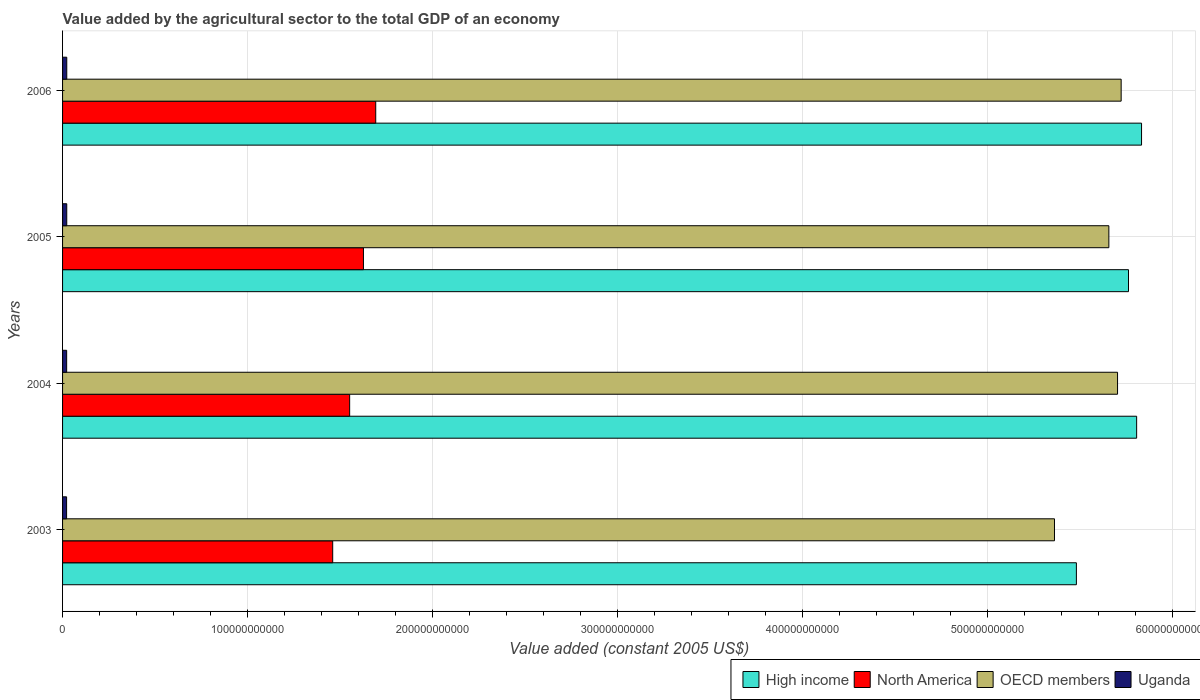In how many cases, is the number of bars for a given year not equal to the number of legend labels?
Your response must be concise. 0. What is the value added by the agricultural sector in OECD members in 2006?
Give a very brief answer. 5.72e+11. Across all years, what is the maximum value added by the agricultural sector in High income?
Your response must be concise. 5.84e+11. Across all years, what is the minimum value added by the agricultural sector in Uganda?
Give a very brief answer. 2.18e+09. In which year was the value added by the agricultural sector in North America maximum?
Offer a very short reply. 2006. What is the total value added by the agricultural sector in High income in the graph?
Provide a succinct answer. 2.29e+12. What is the difference between the value added by the agricultural sector in High income in 2004 and that in 2005?
Your answer should be compact. 4.40e+09. What is the difference between the value added by the agricultural sector in OECD members in 2005 and the value added by the agricultural sector in High income in 2003?
Provide a succinct answer. 1.76e+1. What is the average value added by the agricultural sector in High income per year?
Offer a very short reply. 5.72e+11. In the year 2004, what is the difference between the value added by the agricultural sector in OECD members and value added by the agricultural sector in Uganda?
Offer a terse response. 5.68e+11. What is the ratio of the value added by the agricultural sector in OECD members in 2003 to that in 2006?
Give a very brief answer. 0.94. Is the value added by the agricultural sector in North America in 2003 less than that in 2005?
Offer a terse response. Yes. Is the difference between the value added by the agricultural sector in OECD members in 2003 and 2006 greater than the difference between the value added by the agricultural sector in Uganda in 2003 and 2006?
Provide a succinct answer. No. What is the difference between the highest and the second highest value added by the agricultural sector in High income?
Give a very brief answer. 2.66e+09. What is the difference between the highest and the lowest value added by the agricultural sector in Uganda?
Give a very brief answer. 9.04e+07. Is the sum of the value added by the agricultural sector in Uganda in 2003 and 2006 greater than the maximum value added by the agricultural sector in North America across all years?
Offer a terse response. No. What does the 1st bar from the top in 2004 represents?
Offer a terse response. Uganda. How many bars are there?
Your answer should be compact. 16. Are all the bars in the graph horizontal?
Your answer should be very brief. Yes. How many years are there in the graph?
Ensure brevity in your answer.  4. What is the difference between two consecutive major ticks on the X-axis?
Your response must be concise. 1.00e+11. Are the values on the major ticks of X-axis written in scientific E-notation?
Offer a terse response. No. Does the graph contain any zero values?
Your response must be concise. No. Where does the legend appear in the graph?
Offer a very short reply. Bottom right. What is the title of the graph?
Offer a terse response. Value added by the agricultural sector to the total GDP of an economy. Does "High income: nonOECD" appear as one of the legend labels in the graph?
Provide a short and direct response. No. What is the label or title of the X-axis?
Your answer should be very brief. Value added (constant 2005 US$). What is the Value added (constant 2005 US$) of High income in 2003?
Give a very brief answer. 5.48e+11. What is the Value added (constant 2005 US$) of North America in 2003?
Give a very brief answer. 1.46e+11. What is the Value added (constant 2005 US$) of OECD members in 2003?
Make the answer very short. 5.36e+11. What is the Value added (constant 2005 US$) in Uganda in 2003?
Your answer should be very brief. 2.18e+09. What is the Value added (constant 2005 US$) of High income in 2004?
Provide a succinct answer. 5.81e+11. What is the Value added (constant 2005 US$) of North America in 2004?
Your answer should be very brief. 1.55e+11. What is the Value added (constant 2005 US$) in OECD members in 2004?
Give a very brief answer. 5.71e+11. What is the Value added (constant 2005 US$) of Uganda in 2004?
Make the answer very short. 2.21e+09. What is the Value added (constant 2005 US$) in High income in 2005?
Offer a terse response. 5.76e+11. What is the Value added (constant 2005 US$) of North America in 2005?
Offer a terse response. 1.63e+11. What is the Value added (constant 2005 US$) in OECD members in 2005?
Your response must be concise. 5.66e+11. What is the Value added (constant 2005 US$) of Uganda in 2005?
Ensure brevity in your answer.  2.26e+09. What is the Value added (constant 2005 US$) of High income in 2006?
Your answer should be compact. 5.84e+11. What is the Value added (constant 2005 US$) of North America in 2006?
Give a very brief answer. 1.69e+11. What is the Value added (constant 2005 US$) in OECD members in 2006?
Your response must be concise. 5.72e+11. What is the Value added (constant 2005 US$) in Uganda in 2006?
Make the answer very short. 2.27e+09. Across all years, what is the maximum Value added (constant 2005 US$) of High income?
Your response must be concise. 5.84e+11. Across all years, what is the maximum Value added (constant 2005 US$) of North America?
Your answer should be very brief. 1.69e+11. Across all years, what is the maximum Value added (constant 2005 US$) of OECD members?
Ensure brevity in your answer.  5.72e+11. Across all years, what is the maximum Value added (constant 2005 US$) of Uganda?
Provide a succinct answer. 2.27e+09. Across all years, what is the minimum Value added (constant 2005 US$) in High income?
Your response must be concise. 5.48e+11. Across all years, what is the minimum Value added (constant 2005 US$) in North America?
Keep it short and to the point. 1.46e+11. Across all years, what is the minimum Value added (constant 2005 US$) of OECD members?
Your response must be concise. 5.36e+11. Across all years, what is the minimum Value added (constant 2005 US$) of Uganda?
Ensure brevity in your answer.  2.18e+09. What is the total Value added (constant 2005 US$) in High income in the graph?
Provide a succinct answer. 2.29e+12. What is the total Value added (constant 2005 US$) in North America in the graph?
Offer a terse response. 6.33e+11. What is the total Value added (constant 2005 US$) of OECD members in the graph?
Make the answer very short. 2.25e+12. What is the total Value added (constant 2005 US$) in Uganda in the graph?
Provide a succinct answer. 8.93e+09. What is the difference between the Value added (constant 2005 US$) of High income in 2003 and that in 2004?
Give a very brief answer. -3.26e+1. What is the difference between the Value added (constant 2005 US$) of North America in 2003 and that in 2004?
Give a very brief answer. -9.17e+09. What is the difference between the Value added (constant 2005 US$) in OECD members in 2003 and that in 2004?
Your answer should be compact. -3.41e+1. What is the difference between the Value added (constant 2005 US$) in Uganda in 2003 and that in 2004?
Your answer should be very brief. -3.46e+07. What is the difference between the Value added (constant 2005 US$) of High income in 2003 and that in 2005?
Keep it short and to the point. -2.82e+1. What is the difference between the Value added (constant 2005 US$) in North America in 2003 and that in 2005?
Ensure brevity in your answer.  -1.66e+1. What is the difference between the Value added (constant 2005 US$) in OECD members in 2003 and that in 2005?
Your answer should be compact. -2.94e+1. What is the difference between the Value added (constant 2005 US$) in Uganda in 2003 and that in 2005?
Offer a terse response. -8.00e+07. What is the difference between the Value added (constant 2005 US$) of High income in 2003 and that in 2006?
Provide a succinct answer. -3.52e+1. What is the difference between the Value added (constant 2005 US$) of North America in 2003 and that in 2006?
Give a very brief answer. -2.33e+1. What is the difference between the Value added (constant 2005 US$) of OECD members in 2003 and that in 2006?
Give a very brief answer. -3.61e+1. What is the difference between the Value added (constant 2005 US$) of Uganda in 2003 and that in 2006?
Keep it short and to the point. -9.04e+07. What is the difference between the Value added (constant 2005 US$) in High income in 2004 and that in 2005?
Make the answer very short. 4.40e+09. What is the difference between the Value added (constant 2005 US$) in North America in 2004 and that in 2005?
Provide a succinct answer. -7.46e+09. What is the difference between the Value added (constant 2005 US$) in OECD members in 2004 and that in 2005?
Make the answer very short. 4.70e+09. What is the difference between the Value added (constant 2005 US$) in Uganda in 2004 and that in 2005?
Offer a terse response. -4.54e+07. What is the difference between the Value added (constant 2005 US$) in High income in 2004 and that in 2006?
Offer a very short reply. -2.66e+09. What is the difference between the Value added (constant 2005 US$) in North America in 2004 and that in 2006?
Keep it short and to the point. -1.41e+1. What is the difference between the Value added (constant 2005 US$) in OECD members in 2004 and that in 2006?
Your answer should be compact. -1.95e+09. What is the difference between the Value added (constant 2005 US$) in Uganda in 2004 and that in 2006?
Keep it short and to the point. -5.58e+07. What is the difference between the Value added (constant 2005 US$) in High income in 2005 and that in 2006?
Offer a terse response. -7.05e+09. What is the difference between the Value added (constant 2005 US$) in North America in 2005 and that in 2006?
Provide a succinct answer. -6.64e+09. What is the difference between the Value added (constant 2005 US$) of OECD members in 2005 and that in 2006?
Provide a short and direct response. -6.65e+09. What is the difference between the Value added (constant 2005 US$) in Uganda in 2005 and that in 2006?
Offer a very short reply. -1.04e+07. What is the difference between the Value added (constant 2005 US$) of High income in 2003 and the Value added (constant 2005 US$) of North America in 2004?
Keep it short and to the point. 3.93e+11. What is the difference between the Value added (constant 2005 US$) in High income in 2003 and the Value added (constant 2005 US$) in OECD members in 2004?
Offer a terse response. -2.23e+1. What is the difference between the Value added (constant 2005 US$) of High income in 2003 and the Value added (constant 2005 US$) of Uganda in 2004?
Your response must be concise. 5.46e+11. What is the difference between the Value added (constant 2005 US$) in North America in 2003 and the Value added (constant 2005 US$) in OECD members in 2004?
Ensure brevity in your answer.  -4.24e+11. What is the difference between the Value added (constant 2005 US$) in North America in 2003 and the Value added (constant 2005 US$) in Uganda in 2004?
Ensure brevity in your answer.  1.44e+11. What is the difference between the Value added (constant 2005 US$) in OECD members in 2003 and the Value added (constant 2005 US$) in Uganda in 2004?
Your response must be concise. 5.34e+11. What is the difference between the Value added (constant 2005 US$) in High income in 2003 and the Value added (constant 2005 US$) in North America in 2005?
Provide a short and direct response. 3.86e+11. What is the difference between the Value added (constant 2005 US$) of High income in 2003 and the Value added (constant 2005 US$) of OECD members in 2005?
Your answer should be very brief. -1.76e+1. What is the difference between the Value added (constant 2005 US$) in High income in 2003 and the Value added (constant 2005 US$) in Uganda in 2005?
Your response must be concise. 5.46e+11. What is the difference between the Value added (constant 2005 US$) in North America in 2003 and the Value added (constant 2005 US$) in OECD members in 2005?
Your answer should be compact. -4.20e+11. What is the difference between the Value added (constant 2005 US$) in North America in 2003 and the Value added (constant 2005 US$) in Uganda in 2005?
Offer a terse response. 1.44e+11. What is the difference between the Value added (constant 2005 US$) in OECD members in 2003 and the Value added (constant 2005 US$) in Uganda in 2005?
Ensure brevity in your answer.  5.34e+11. What is the difference between the Value added (constant 2005 US$) in High income in 2003 and the Value added (constant 2005 US$) in North America in 2006?
Make the answer very short. 3.79e+11. What is the difference between the Value added (constant 2005 US$) of High income in 2003 and the Value added (constant 2005 US$) of OECD members in 2006?
Provide a succinct answer. -2.42e+1. What is the difference between the Value added (constant 2005 US$) in High income in 2003 and the Value added (constant 2005 US$) in Uganda in 2006?
Keep it short and to the point. 5.46e+11. What is the difference between the Value added (constant 2005 US$) in North America in 2003 and the Value added (constant 2005 US$) in OECD members in 2006?
Keep it short and to the point. -4.26e+11. What is the difference between the Value added (constant 2005 US$) of North America in 2003 and the Value added (constant 2005 US$) of Uganda in 2006?
Keep it short and to the point. 1.44e+11. What is the difference between the Value added (constant 2005 US$) in OECD members in 2003 and the Value added (constant 2005 US$) in Uganda in 2006?
Give a very brief answer. 5.34e+11. What is the difference between the Value added (constant 2005 US$) in High income in 2004 and the Value added (constant 2005 US$) in North America in 2005?
Provide a succinct answer. 4.18e+11. What is the difference between the Value added (constant 2005 US$) of High income in 2004 and the Value added (constant 2005 US$) of OECD members in 2005?
Give a very brief answer. 1.50e+1. What is the difference between the Value added (constant 2005 US$) of High income in 2004 and the Value added (constant 2005 US$) of Uganda in 2005?
Keep it short and to the point. 5.79e+11. What is the difference between the Value added (constant 2005 US$) in North America in 2004 and the Value added (constant 2005 US$) in OECD members in 2005?
Give a very brief answer. -4.11e+11. What is the difference between the Value added (constant 2005 US$) in North America in 2004 and the Value added (constant 2005 US$) in Uganda in 2005?
Your answer should be compact. 1.53e+11. What is the difference between the Value added (constant 2005 US$) in OECD members in 2004 and the Value added (constant 2005 US$) in Uganda in 2005?
Offer a very short reply. 5.68e+11. What is the difference between the Value added (constant 2005 US$) in High income in 2004 and the Value added (constant 2005 US$) in North America in 2006?
Your response must be concise. 4.12e+11. What is the difference between the Value added (constant 2005 US$) of High income in 2004 and the Value added (constant 2005 US$) of OECD members in 2006?
Make the answer very short. 8.37e+09. What is the difference between the Value added (constant 2005 US$) of High income in 2004 and the Value added (constant 2005 US$) of Uganda in 2006?
Offer a terse response. 5.79e+11. What is the difference between the Value added (constant 2005 US$) in North America in 2004 and the Value added (constant 2005 US$) in OECD members in 2006?
Offer a terse response. -4.17e+11. What is the difference between the Value added (constant 2005 US$) of North America in 2004 and the Value added (constant 2005 US$) of Uganda in 2006?
Provide a short and direct response. 1.53e+11. What is the difference between the Value added (constant 2005 US$) in OECD members in 2004 and the Value added (constant 2005 US$) in Uganda in 2006?
Provide a succinct answer. 5.68e+11. What is the difference between the Value added (constant 2005 US$) of High income in 2005 and the Value added (constant 2005 US$) of North America in 2006?
Make the answer very short. 4.07e+11. What is the difference between the Value added (constant 2005 US$) in High income in 2005 and the Value added (constant 2005 US$) in OECD members in 2006?
Provide a short and direct response. 3.97e+09. What is the difference between the Value added (constant 2005 US$) of High income in 2005 and the Value added (constant 2005 US$) of Uganda in 2006?
Ensure brevity in your answer.  5.74e+11. What is the difference between the Value added (constant 2005 US$) of North America in 2005 and the Value added (constant 2005 US$) of OECD members in 2006?
Provide a short and direct response. -4.10e+11. What is the difference between the Value added (constant 2005 US$) of North America in 2005 and the Value added (constant 2005 US$) of Uganda in 2006?
Offer a very short reply. 1.60e+11. What is the difference between the Value added (constant 2005 US$) in OECD members in 2005 and the Value added (constant 2005 US$) in Uganda in 2006?
Provide a succinct answer. 5.64e+11. What is the average Value added (constant 2005 US$) in High income per year?
Ensure brevity in your answer.  5.72e+11. What is the average Value added (constant 2005 US$) in North America per year?
Give a very brief answer. 1.58e+11. What is the average Value added (constant 2005 US$) of OECD members per year?
Provide a short and direct response. 5.61e+11. What is the average Value added (constant 2005 US$) in Uganda per year?
Your answer should be very brief. 2.23e+09. In the year 2003, what is the difference between the Value added (constant 2005 US$) of High income and Value added (constant 2005 US$) of North America?
Make the answer very short. 4.02e+11. In the year 2003, what is the difference between the Value added (constant 2005 US$) in High income and Value added (constant 2005 US$) in OECD members?
Offer a very short reply. 1.18e+1. In the year 2003, what is the difference between the Value added (constant 2005 US$) in High income and Value added (constant 2005 US$) in Uganda?
Make the answer very short. 5.46e+11. In the year 2003, what is the difference between the Value added (constant 2005 US$) in North America and Value added (constant 2005 US$) in OECD members?
Give a very brief answer. -3.90e+11. In the year 2003, what is the difference between the Value added (constant 2005 US$) of North America and Value added (constant 2005 US$) of Uganda?
Provide a short and direct response. 1.44e+11. In the year 2003, what is the difference between the Value added (constant 2005 US$) in OECD members and Value added (constant 2005 US$) in Uganda?
Ensure brevity in your answer.  5.34e+11. In the year 2004, what is the difference between the Value added (constant 2005 US$) of High income and Value added (constant 2005 US$) of North America?
Keep it short and to the point. 4.26e+11. In the year 2004, what is the difference between the Value added (constant 2005 US$) of High income and Value added (constant 2005 US$) of OECD members?
Make the answer very short. 1.03e+1. In the year 2004, what is the difference between the Value added (constant 2005 US$) of High income and Value added (constant 2005 US$) of Uganda?
Your answer should be very brief. 5.79e+11. In the year 2004, what is the difference between the Value added (constant 2005 US$) of North America and Value added (constant 2005 US$) of OECD members?
Your answer should be compact. -4.15e+11. In the year 2004, what is the difference between the Value added (constant 2005 US$) of North America and Value added (constant 2005 US$) of Uganda?
Make the answer very short. 1.53e+11. In the year 2004, what is the difference between the Value added (constant 2005 US$) of OECD members and Value added (constant 2005 US$) of Uganda?
Your response must be concise. 5.68e+11. In the year 2005, what is the difference between the Value added (constant 2005 US$) in High income and Value added (constant 2005 US$) in North America?
Your answer should be compact. 4.14e+11. In the year 2005, what is the difference between the Value added (constant 2005 US$) of High income and Value added (constant 2005 US$) of OECD members?
Give a very brief answer. 1.06e+1. In the year 2005, what is the difference between the Value added (constant 2005 US$) in High income and Value added (constant 2005 US$) in Uganda?
Offer a terse response. 5.74e+11. In the year 2005, what is the difference between the Value added (constant 2005 US$) in North America and Value added (constant 2005 US$) in OECD members?
Ensure brevity in your answer.  -4.03e+11. In the year 2005, what is the difference between the Value added (constant 2005 US$) in North America and Value added (constant 2005 US$) in Uganda?
Make the answer very short. 1.60e+11. In the year 2005, what is the difference between the Value added (constant 2005 US$) of OECD members and Value added (constant 2005 US$) of Uganda?
Your response must be concise. 5.64e+11. In the year 2006, what is the difference between the Value added (constant 2005 US$) of High income and Value added (constant 2005 US$) of North America?
Ensure brevity in your answer.  4.14e+11. In the year 2006, what is the difference between the Value added (constant 2005 US$) of High income and Value added (constant 2005 US$) of OECD members?
Provide a succinct answer. 1.10e+1. In the year 2006, what is the difference between the Value added (constant 2005 US$) of High income and Value added (constant 2005 US$) of Uganda?
Give a very brief answer. 5.81e+11. In the year 2006, what is the difference between the Value added (constant 2005 US$) of North America and Value added (constant 2005 US$) of OECD members?
Your answer should be very brief. -4.03e+11. In the year 2006, what is the difference between the Value added (constant 2005 US$) of North America and Value added (constant 2005 US$) of Uganda?
Your answer should be compact. 1.67e+11. In the year 2006, what is the difference between the Value added (constant 2005 US$) in OECD members and Value added (constant 2005 US$) in Uganda?
Your response must be concise. 5.70e+11. What is the ratio of the Value added (constant 2005 US$) of High income in 2003 to that in 2004?
Give a very brief answer. 0.94. What is the ratio of the Value added (constant 2005 US$) of North America in 2003 to that in 2004?
Provide a short and direct response. 0.94. What is the ratio of the Value added (constant 2005 US$) of OECD members in 2003 to that in 2004?
Keep it short and to the point. 0.94. What is the ratio of the Value added (constant 2005 US$) of Uganda in 2003 to that in 2004?
Provide a succinct answer. 0.98. What is the ratio of the Value added (constant 2005 US$) in High income in 2003 to that in 2005?
Offer a terse response. 0.95. What is the ratio of the Value added (constant 2005 US$) of North America in 2003 to that in 2005?
Provide a short and direct response. 0.9. What is the ratio of the Value added (constant 2005 US$) of OECD members in 2003 to that in 2005?
Give a very brief answer. 0.95. What is the ratio of the Value added (constant 2005 US$) of Uganda in 2003 to that in 2005?
Give a very brief answer. 0.96. What is the ratio of the Value added (constant 2005 US$) of High income in 2003 to that in 2006?
Offer a very short reply. 0.94. What is the ratio of the Value added (constant 2005 US$) in North America in 2003 to that in 2006?
Make the answer very short. 0.86. What is the ratio of the Value added (constant 2005 US$) in OECD members in 2003 to that in 2006?
Keep it short and to the point. 0.94. What is the ratio of the Value added (constant 2005 US$) of Uganda in 2003 to that in 2006?
Keep it short and to the point. 0.96. What is the ratio of the Value added (constant 2005 US$) of High income in 2004 to that in 2005?
Provide a short and direct response. 1.01. What is the ratio of the Value added (constant 2005 US$) of North America in 2004 to that in 2005?
Your response must be concise. 0.95. What is the ratio of the Value added (constant 2005 US$) in OECD members in 2004 to that in 2005?
Provide a succinct answer. 1.01. What is the ratio of the Value added (constant 2005 US$) of Uganda in 2004 to that in 2005?
Offer a terse response. 0.98. What is the ratio of the Value added (constant 2005 US$) of OECD members in 2004 to that in 2006?
Your answer should be very brief. 1. What is the ratio of the Value added (constant 2005 US$) in Uganda in 2004 to that in 2006?
Ensure brevity in your answer.  0.98. What is the ratio of the Value added (constant 2005 US$) in High income in 2005 to that in 2006?
Keep it short and to the point. 0.99. What is the ratio of the Value added (constant 2005 US$) of North America in 2005 to that in 2006?
Make the answer very short. 0.96. What is the ratio of the Value added (constant 2005 US$) of OECD members in 2005 to that in 2006?
Ensure brevity in your answer.  0.99. What is the ratio of the Value added (constant 2005 US$) in Uganda in 2005 to that in 2006?
Provide a short and direct response. 1. What is the difference between the highest and the second highest Value added (constant 2005 US$) in High income?
Your answer should be compact. 2.66e+09. What is the difference between the highest and the second highest Value added (constant 2005 US$) of North America?
Your answer should be very brief. 6.64e+09. What is the difference between the highest and the second highest Value added (constant 2005 US$) of OECD members?
Offer a terse response. 1.95e+09. What is the difference between the highest and the second highest Value added (constant 2005 US$) of Uganda?
Your answer should be very brief. 1.04e+07. What is the difference between the highest and the lowest Value added (constant 2005 US$) in High income?
Offer a very short reply. 3.52e+1. What is the difference between the highest and the lowest Value added (constant 2005 US$) in North America?
Provide a succinct answer. 2.33e+1. What is the difference between the highest and the lowest Value added (constant 2005 US$) of OECD members?
Provide a succinct answer. 3.61e+1. What is the difference between the highest and the lowest Value added (constant 2005 US$) in Uganda?
Ensure brevity in your answer.  9.04e+07. 